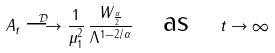Convert formula to latex. <formula><loc_0><loc_0><loc_500><loc_500>A _ { t } \stackrel { \mathcal { D } } { \longrightarrow } \frac { 1 } { \mu _ { 1 } ^ { 2 } } \, \frac { W _ { \frac { \alpha } { 2 } } } { \Lambda ^ { 1 - 2 / \alpha } } \quad \text {as} \quad t \rightarrow \infty</formula> 